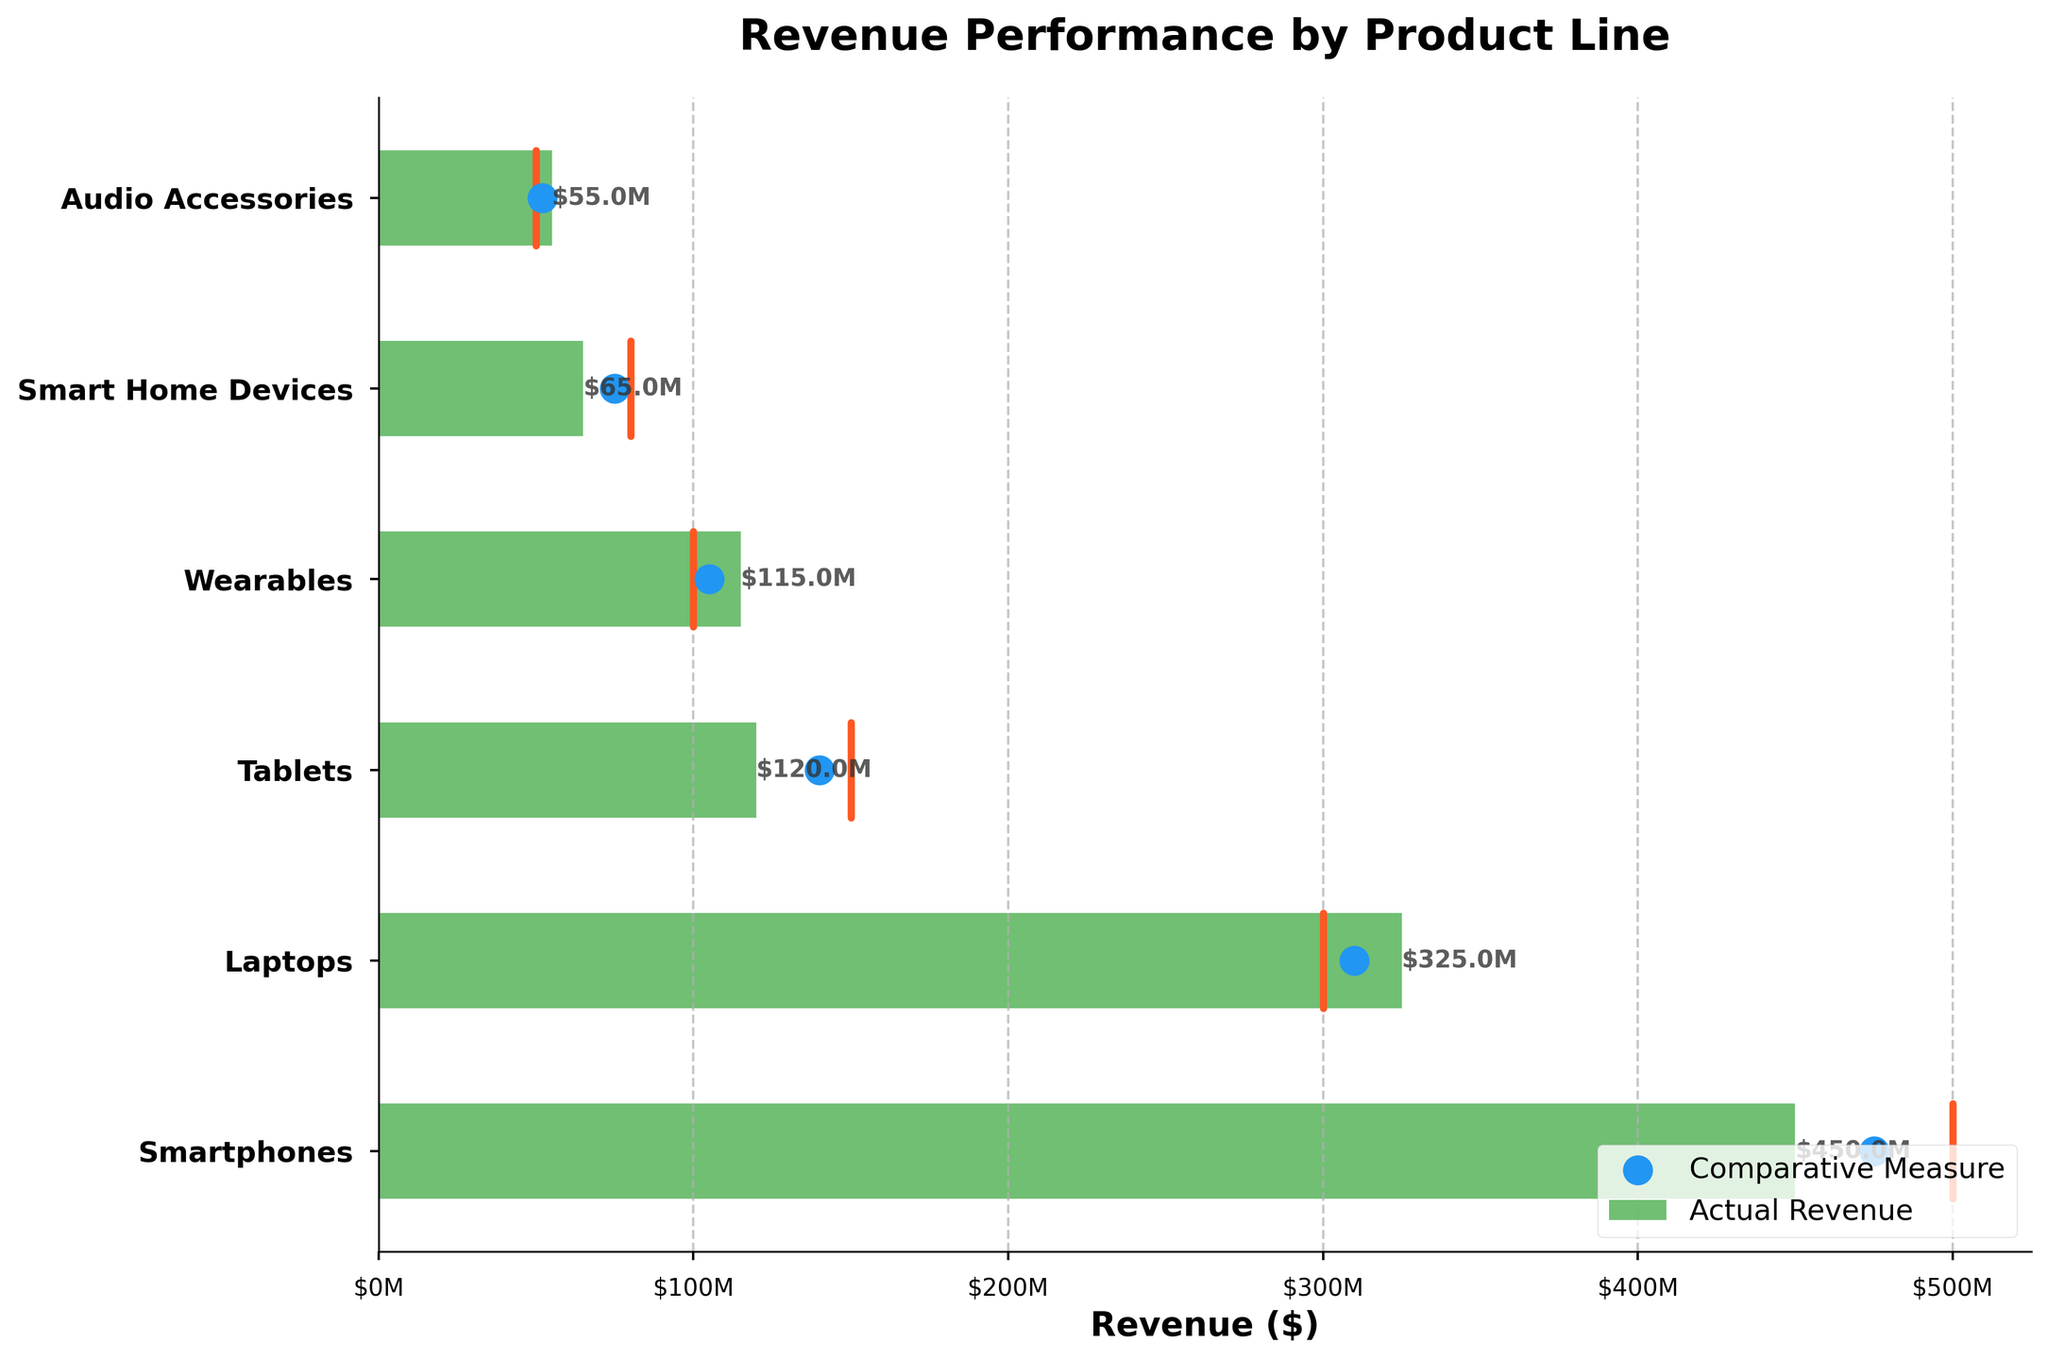What is the title of the chart? The title is usually displayed at the top of the chart. From the code, it is set using the `ax.set_title` method.
Answer: Revenue Performance by Product Line How many product lines are being compared in this chart? The number of product lines corresponds to the number of horizontal bars on the y-axis. From the data, there are 6 product lines.
Answer: 6 What color represents the Comparative Measure in the chart? The color of the Comparative Measure is defined in the code by `color='#2196F3'`, which is a shade of blue.
Answer: Blue Which product line exceeded its target revenue? To determine which product line exceeded its target revenue, compare the Actual Revenue bars to the Target Revenue lines. Wearables and Audio Accessories have Actual Revenues exceeding their target lines.
Answer: Wearables and Audio Accessories What is the actual revenue for Laptops in millions of dollars? The actual revenue for Laptops is given directly in the data: $325,000,000. Divide by 1,000,000 to convert to millions.
Answer: $325 million For which product line is the difference between Actual Revenue and Target Revenue the largest? Calculate the difference for each product line:
   - Smartphones: $450M - $500M = -$50M
   - Laptops: $325M - $300M = +$25M
   - Tablets: $120M - $150M = -$30M
   - Wearables: $115M - $100M = +$15M
   - Smart Home Devices: $65M - $80M = -$15M
   - Audio Accessories: $55M - $50M = +$5M
   The largest absolute difference is -$50M for Smartphones.
Answer: Smartphones Compare the Actual Revenue of Smart Home Devices and Comparative Measure. Which is greater? Check Smart Home Devices' Actual Revenue ($65M) and Comparative Measure ($75M).
Answer: Comparative Measure What radial marker style is used to represent Comparative Measure? According to the code (`ax.scatter`), markers for Comparative Measure are displayed as points (scatter plot) with a larger size (`s=150`).
Answer: Points Calculate the average of the Comparative Measures for all product lines. Sum of Comparative Measures divided by the number of product lines:
   ($475M + $310M + $140M + $105M + $75M + $52M) / 6 = $1157M / 6 = $192.83M
Answer: $192.83 million How close is the Actual Revenue of Wearables to its Target Revenue in percentage? Calculate the percentage difference:
   [($115M - $100M) / $100M] * 100% = 15%
Answer: 15% 